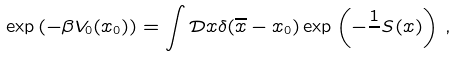<formula> <loc_0><loc_0><loc_500><loc_500>\exp \left ( - { \beta } V _ { 0 } ( x _ { 0 } ) \right ) = \int \mathcal { D } x \delta ( \overline { x } - x _ { 0 } ) \exp \left ( - \frac { 1 } { } S ( x ) \right ) \, ,</formula> 